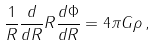<formula> <loc_0><loc_0><loc_500><loc_500>\frac { 1 } { R } \frac { d } { d R } R \frac { d \Phi } { d R } = 4 \pi G \rho \, ,</formula> 